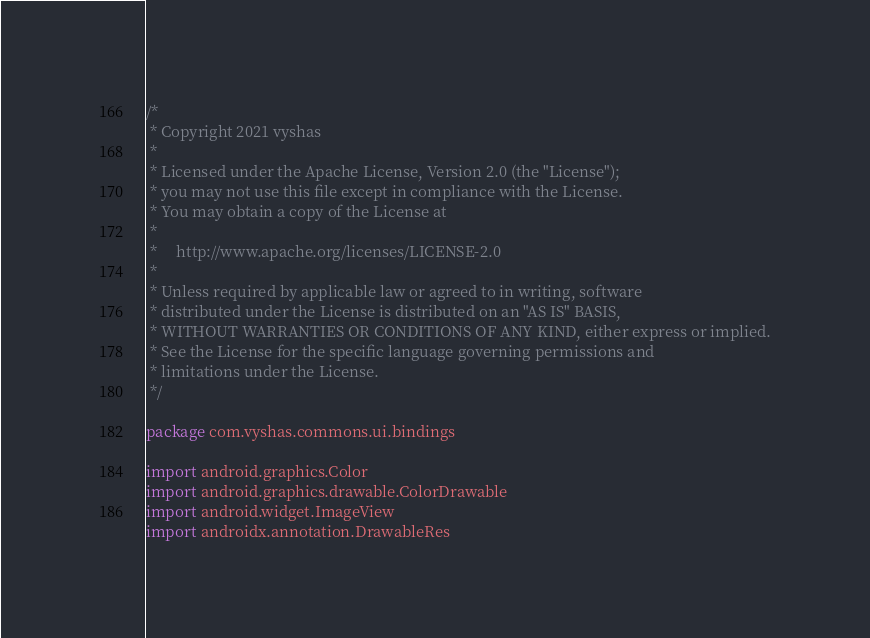<code> <loc_0><loc_0><loc_500><loc_500><_Kotlin_>/*
 * Copyright 2021 vyshas
 *
 * Licensed under the Apache License, Version 2.0 (the "License");
 * you may not use this file except in compliance with the License.
 * You may obtain a copy of the License at
 *
 *     http://www.apache.org/licenses/LICENSE-2.0
 *
 * Unless required by applicable law or agreed to in writing, software
 * distributed under the License is distributed on an "AS IS" BASIS,
 * WITHOUT WARRANTIES OR CONDITIONS OF ANY KIND, either express or implied.
 * See the License for the specific language governing permissions and
 * limitations under the License.
 */

package com.vyshas.commons.ui.bindings

import android.graphics.Color
import android.graphics.drawable.ColorDrawable
import android.widget.ImageView
import androidx.annotation.DrawableRes</code> 